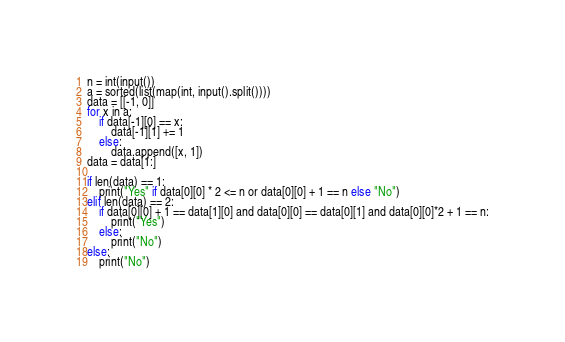<code> <loc_0><loc_0><loc_500><loc_500><_Python_>n = int(input())
a = sorted(list(map(int, input().split())))
data = [[-1, 0]]
for x in a:
    if data[-1][0] == x:
        data[-1][1] += 1
    else:
        data.append([x, 1])
data = data[1:]

if len(data) == 1:
    print("Yes" if data[0][0] * 2 <= n or data[0][0] + 1 == n else "No")
elif len(data) == 2:
    if data[0][0] + 1 == data[1][0] and data[0][0] == data[0][1] and data[0][0]*2 + 1 == n:
        print("Yes")
    else:
        print("No")
else:
    print("No")
</code> 